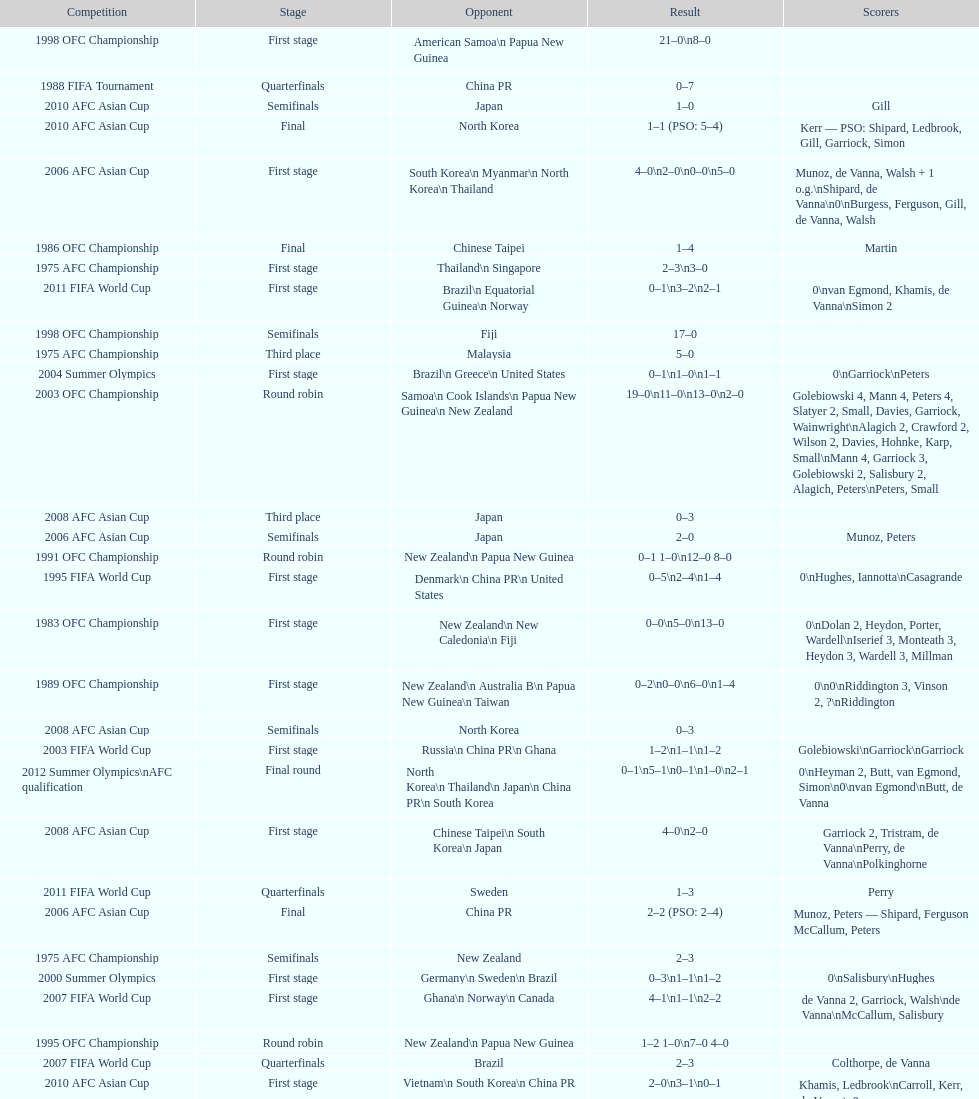Who scored better in the 1995 fifa world cup denmark or the united states? United States. 